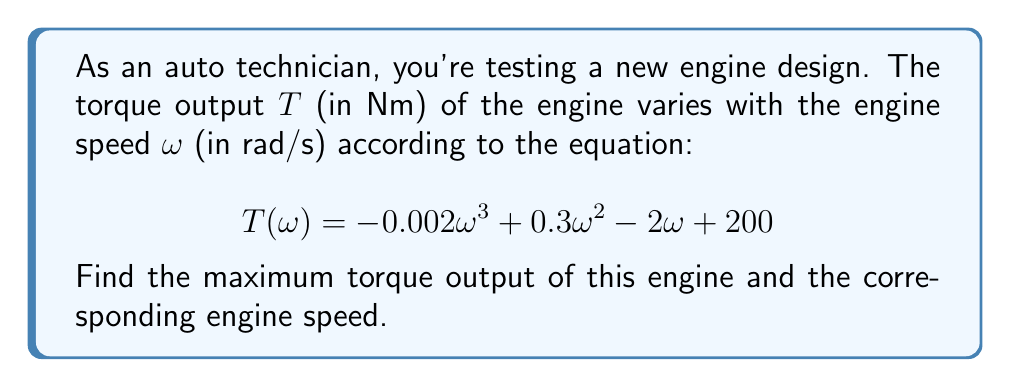Provide a solution to this math problem. To find the maximum torque output, we need to use calculus to find the critical points of the torque function and determine which one gives the maximum value.

1. First, let's find the derivative of the torque function:
   $$\frac{dT}{d\omega} = -0.006\omega^2 + 0.6\omega - 2$$

2. To find the critical points, set the derivative equal to zero:
   $$-0.006\omega^2 + 0.6\omega - 2 = 0$$

3. This is a quadratic equation. We can solve it using the quadratic formula:
   $$\omega = \frac{-b \pm \sqrt{b^2 - 4ac}}{2a}$$
   where $a = -0.006$, $b = 0.6$, and $c = -2$

4. Substituting these values:
   $$\omega = \frac{-0.6 \pm \sqrt{0.6^2 - 4(-0.006)(-2)}}{2(-0.006)}$$
   $$= \frac{-0.6 \pm \sqrt{0.36 - 0.048}}{-0.012}$$
   $$= \frac{-0.6 \pm \sqrt{0.312}}{-0.012}$$
   $$= \frac{-0.6 \pm 0.558846}{-0.012}$$

5. This gives us two critical points:
   $$\omega_1 = \frac{-0.6 + 0.558846}{-0.012} \approx 3.43 \text{ rad/s}$$
   $$\omega_2 = \frac{-0.6 - 0.558846}{-0.012} \approx 96.57 \text{ rad/s}$$

6. To determine which critical point gives the maximum torque, we can either:
   a) Evaluate the torque function at both points and compare, or
   b) Use the second derivative test

   Let's use method (a) for simplicity:

   At $\omega_1 = 3.43$:
   $$T(3.43) = -0.002(3.43)^3 + 0.3(3.43)^2 - 2(3.43) + 200 \approx 200.86 \text{ Nm}$$

   At $\omega_2 = 96.57$:
   $$T(96.57) = -0.002(96.57)^3 + 0.3(96.57)^2 - 2(96.57) + 200 \approx 161.59 \text{ Nm}$$

7. The maximum torque output occurs at $\omega_1 = 3.43 \text{ rad/s}$ and is approximately 200.86 Nm.
Answer: The maximum torque output is approximately 200.86 Nm, occurring at an engine speed of 3.43 rad/s. 